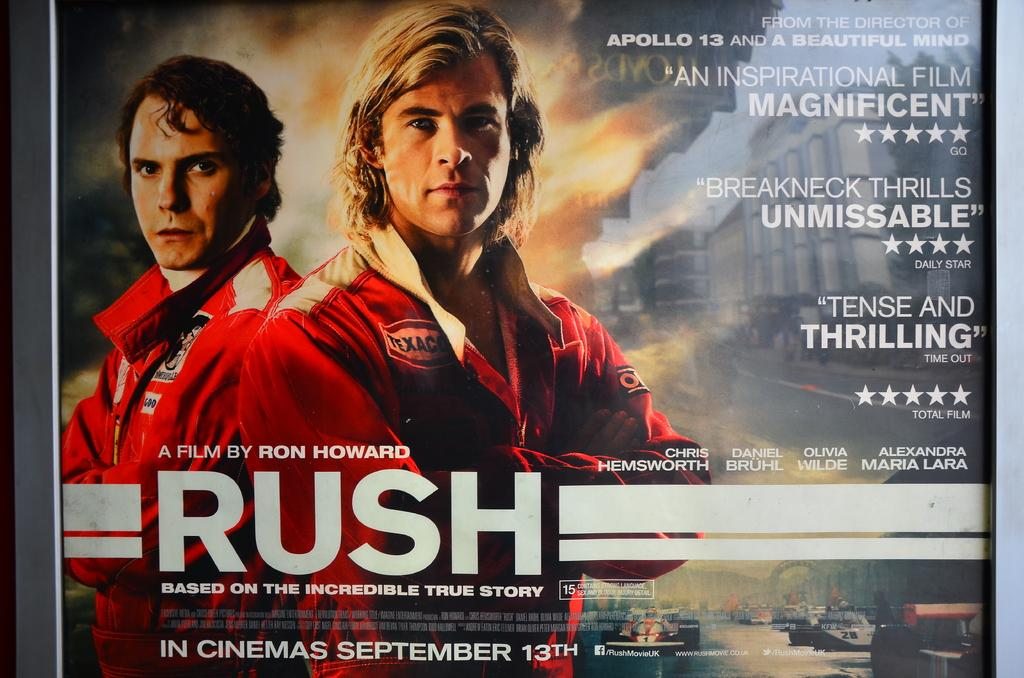<image>
Write a terse but informative summary of the picture. an advertisement for a movie that is called Rush 